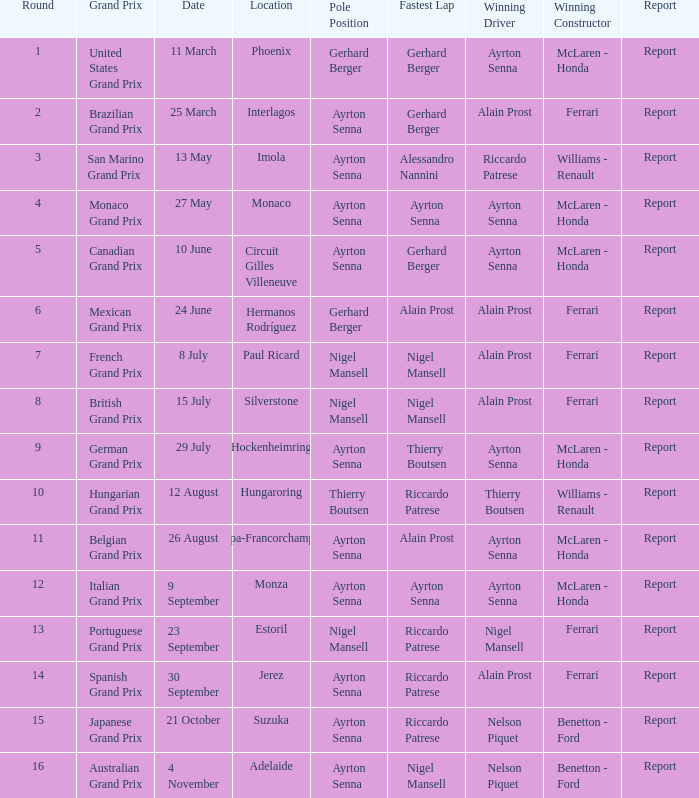When did ayrton senna participate as a driver in monza? 9 September. 